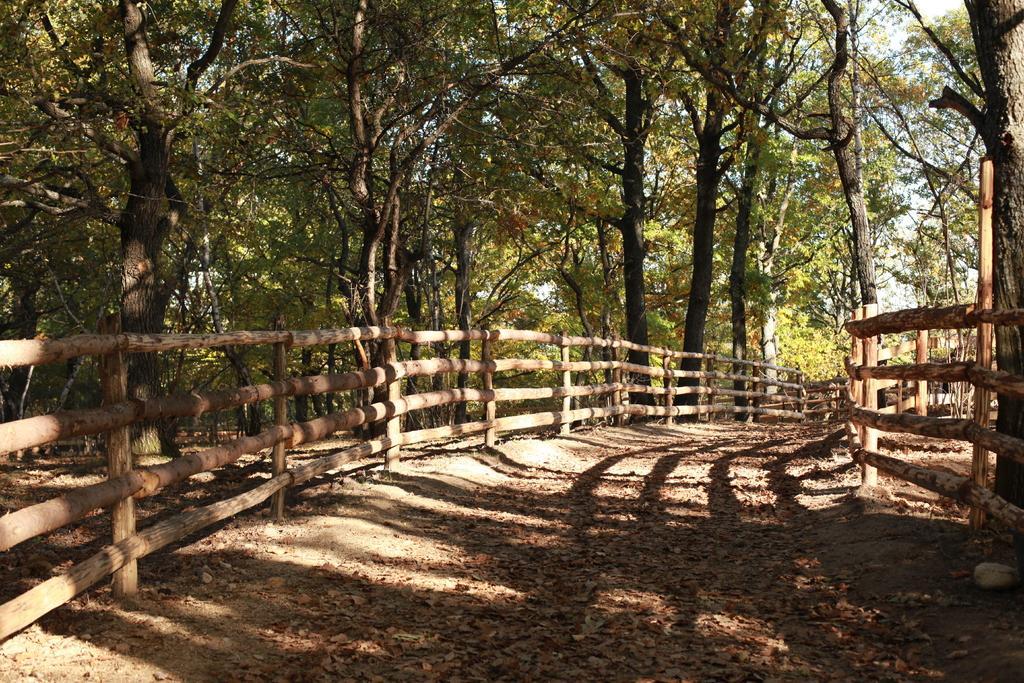Please provide a concise description of this image. At the bottom of the image on the ground there are dry leaves. And there are wooden fencing in the image. In the background there are many trees. 